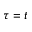<formula> <loc_0><loc_0><loc_500><loc_500>\tau = t</formula> 